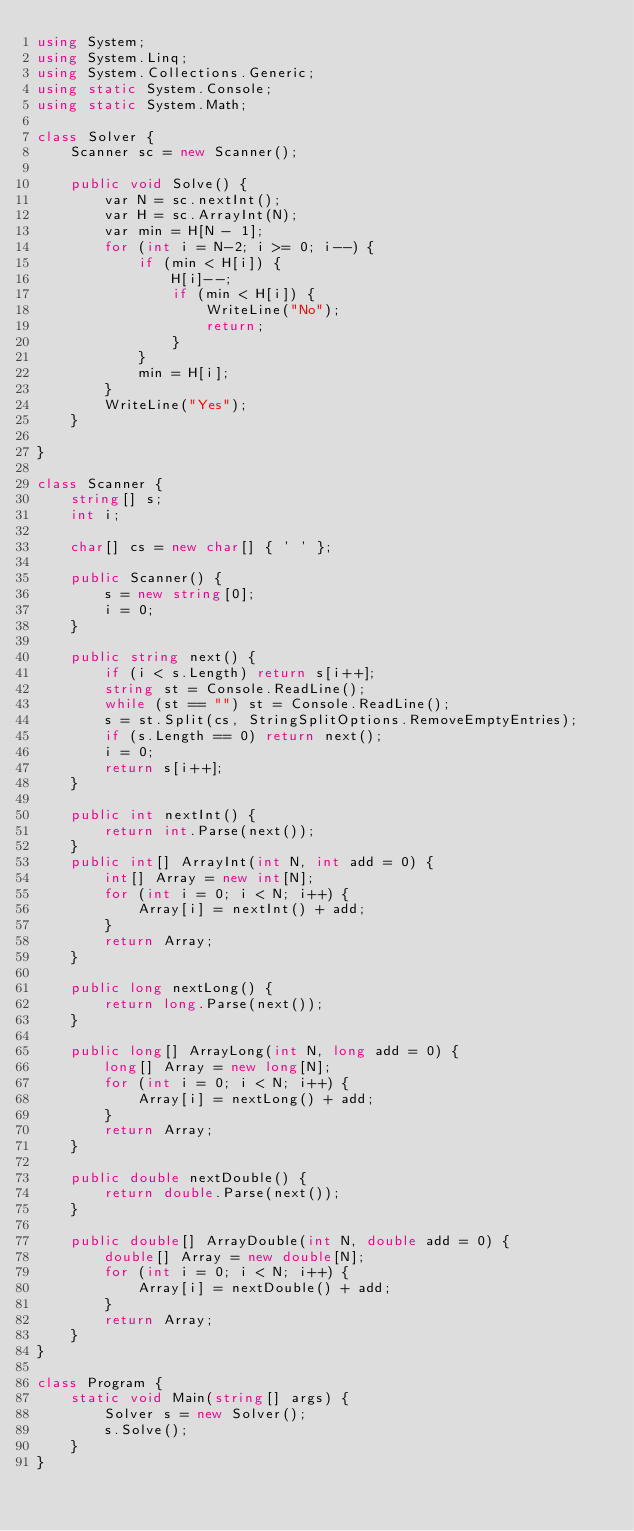Convert code to text. <code><loc_0><loc_0><loc_500><loc_500><_C#_>using System;
using System.Linq;
using System.Collections.Generic;
using static System.Console;
using static System.Math;

class Solver {
    Scanner sc = new Scanner();

    public void Solve() {
        var N = sc.nextInt();
        var H = sc.ArrayInt(N);
        var min = H[N - 1];
        for (int i = N-2; i >= 0; i--) {
            if (min < H[i]) {
                H[i]--;
                if (min < H[i]) {
                    WriteLine("No");
                    return;
                }
            }
            min = H[i];
        }
        WriteLine("Yes");
    }
    
}

class Scanner {
    string[] s;
    int i;

    char[] cs = new char[] { ' ' };

    public Scanner() {
        s = new string[0];
        i = 0;
    }

    public string next() {
        if (i < s.Length) return s[i++];
        string st = Console.ReadLine();
        while (st == "") st = Console.ReadLine();
        s = st.Split(cs, StringSplitOptions.RemoveEmptyEntries);
        if (s.Length == 0) return next();
        i = 0;
        return s[i++];
    }

    public int nextInt() {
        return int.Parse(next());
    }
    public int[] ArrayInt(int N, int add = 0) {
        int[] Array = new int[N];
        for (int i = 0; i < N; i++) {
            Array[i] = nextInt() + add;
        }
        return Array;
    }

    public long nextLong() {
        return long.Parse(next());
    }

    public long[] ArrayLong(int N, long add = 0) {
        long[] Array = new long[N];
        for (int i = 0; i < N; i++) {
            Array[i] = nextLong() + add;
        }
        return Array;
    }

    public double nextDouble() {
        return double.Parse(next());
    }

    public double[] ArrayDouble(int N, double add = 0) {
        double[] Array = new double[N];
        for (int i = 0; i < N; i++) {
            Array[i] = nextDouble() + add;
        }
        return Array;
    }
}

class Program {
    static void Main(string[] args) {
        Solver s = new Solver();
        s.Solve();
    }
}
</code> 